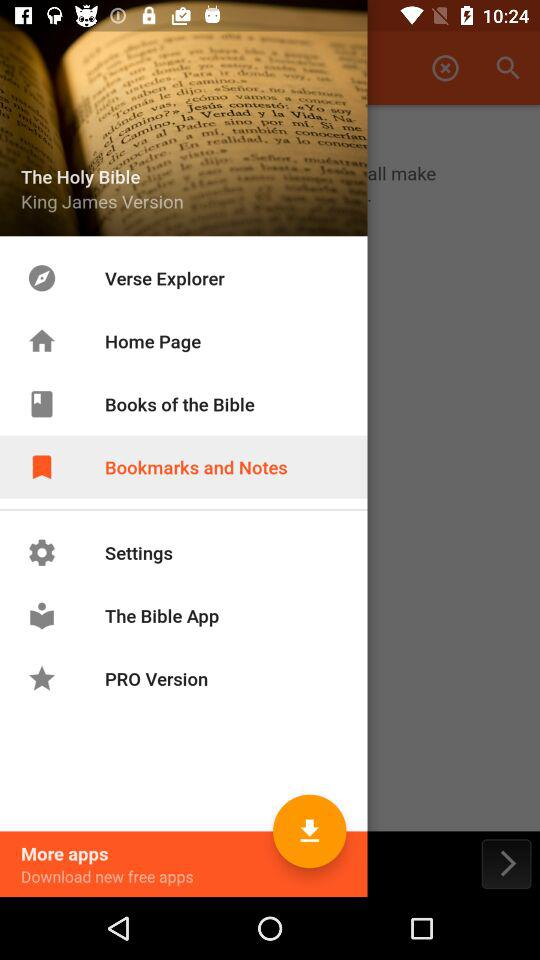Who is the author of the holy bible?
When the provided information is insufficient, respond with <no answer>. <no answer> 